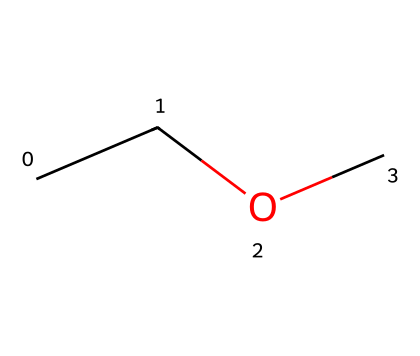What is the name of this chemical? The SMILES representation "CCOC" corresponds to ethyl methyl ether, which has two different alkyl groups, ethyl and methyl, attached to an oxygen atom.
Answer: ethyl methyl ether How many carbon atoms are in this chemical? The SMILES representation "CCOC" indicates that there are a total of three carbon atoms: two from the ethyl group and one from the methyl group.
Answer: three How many oxygen atoms are present in ethyl methyl ether? The structure derived from "CCOC" shows one oxygen atom bonded in the ether, thus there is only one oxygen atom in the molecule.
Answer: one Which functional group is represented in this chemical? Ethers are characterized by the presence of an oxygen atom bonded to two alkyl or aryl groups. In "CCOC," the structure contains an ether functional group defined by the -O- bond.
Answer: ether What is the degree of saturation of ethyl methyl ether? The structure "CCOC" is fully saturated, meaning there are no double or triple bonds present within the molecule, only single bonds connecting the atoms.
Answer: saturated Is ethyl methyl ether likely to be polar or nonpolar? Given the presence of an oxygen atom, which is more electronegative, and its arrangement in the molecule, ethyl methyl ether displays polar characteristics, allowing it to interact with other polar substances.
Answer: polar 